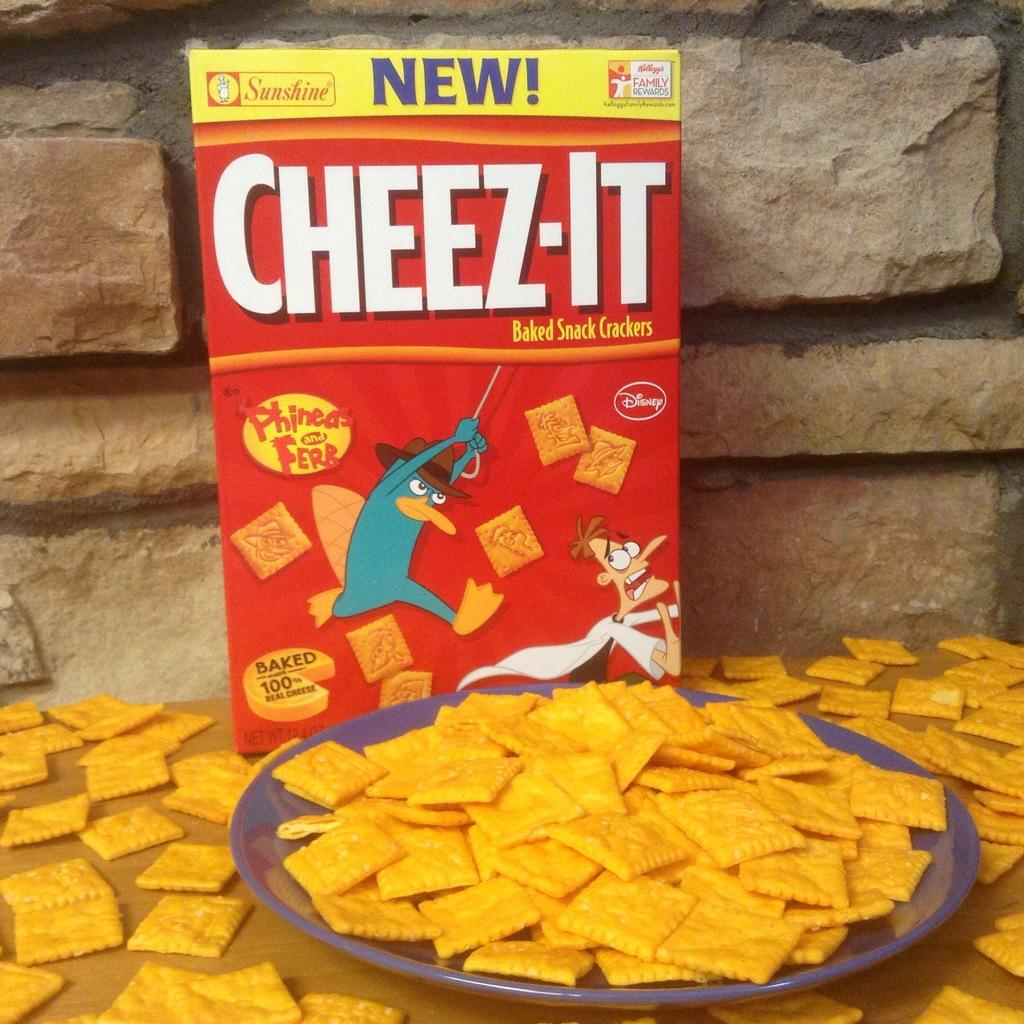Provide a one-sentence caption for the provided image. a BOX OF CHEESE-ITS BEHIND A PLATE FULL OF CHEESE-ITS. 